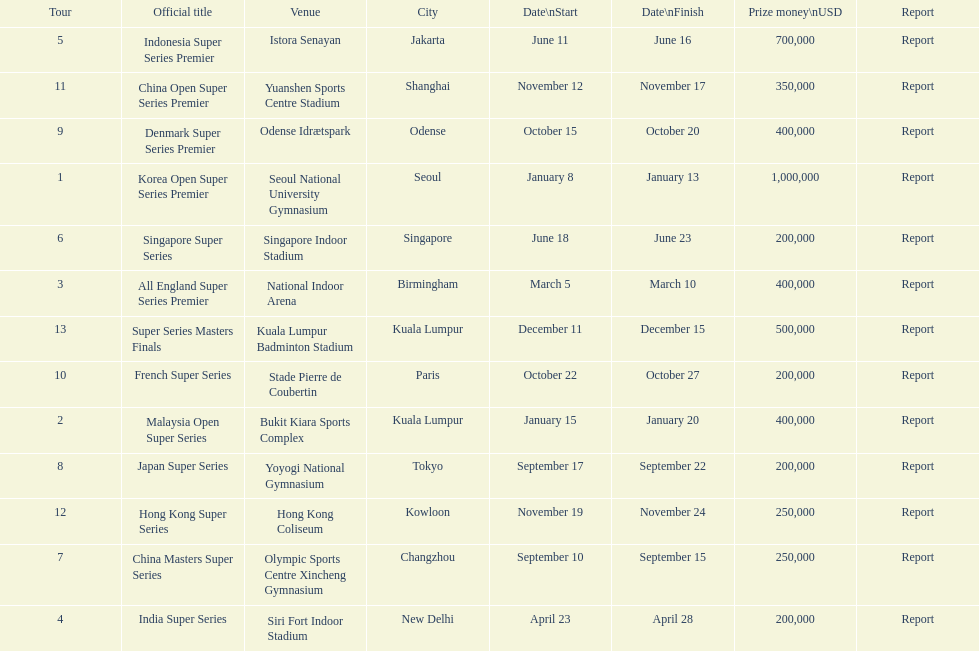Which tour was the only one to take place in december? Super Series Masters Finals. 